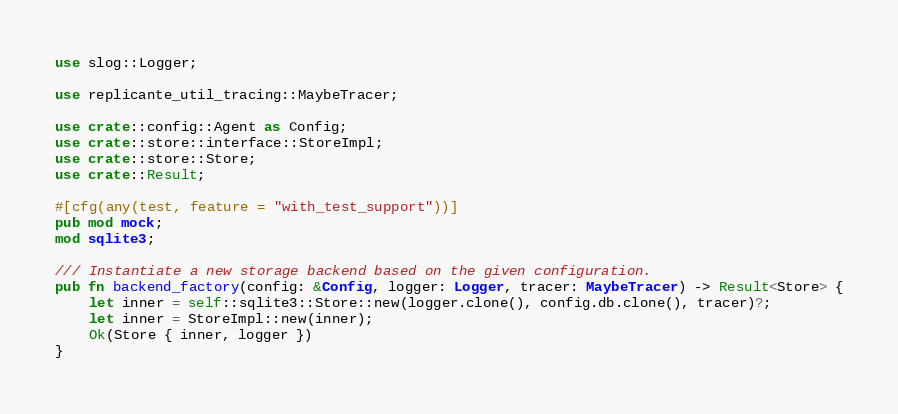<code> <loc_0><loc_0><loc_500><loc_500><_Rust_>use slog::Logger;

use replicante_util_tracing::MaybeTracer;

use crate::config::Agent as Config;
use crate::store::interface::StoreImpl;
use crate::store::Store;
use crate::Result;

#[cfg(any(test, feature = "with_test_support"))]
pub mod mock;
mod sqlite3;

/// Instantiate a new storage backend based on the given configuration.
pub fn backend_factory(config: &Config, logger: Logger, tracer: MaybeTracer) -> Result<Store> {
    let inner = self::sqlite3::Store::new(logger.clone(), config.db.clone(), tracer)?;
    let inner = StoreImpl::new(inner);
    Ok(Store { inner, logger })
}
</code> 